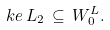<formula> <loc_0><loc_0><loc_500><loc_500>\ k e \, L _ { 2 } \, \subseteq \, W ^ { L } _ { 0 } .</formula> 